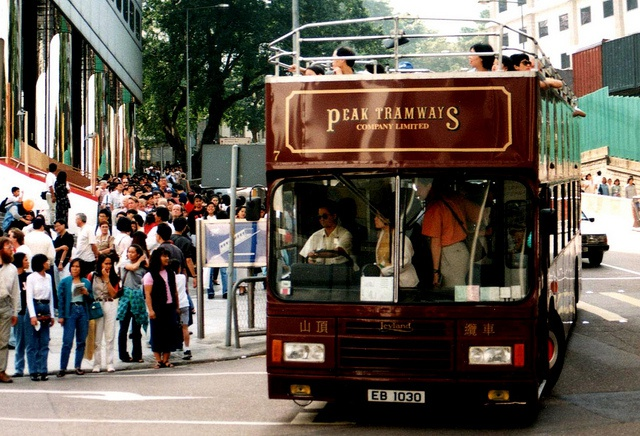Describe the objects in this image and their specific colors. I can see bus in white, black, maroon, ivory, and darkgray tones, people in white, black, darkgray, and gray tones, people in white, black, maroon, and gray tones, people in white, black, maroon, and brown tones, and people in white, black, lavender, navy, and gray tones in this image. 